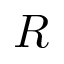<formula> <loc_0><loc_0><loc_500><loc_500>R</formula> 